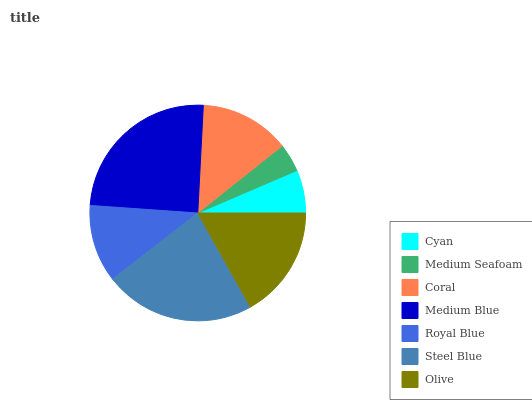Is Medium Seafoam the minimum?
Answer yes or no. Yes. Is Medium Blue the maximum?
Answer yes or no. Yes. Is Coral the minimum?
Answer yes or no. No. Is Coral the maximum?
Answer yes or no. No. Is Coral greater than Medium Seafoam?
Answer yes or no. Yes. Is Medium Seafoam less than Coral?
Answer yes or no. Yes. Is Medium Seafoam greater than Coral?
Answer yes or no. No. Is Coral less than Medium Seafoam?
Answer yes or no. No. Is Coral the high median?
Answer yes or no. Yes. Is Coral the low median?
Answer yes or no. Yes. Is Medium Seafoam the high median?
Answer yes or no. No. Is Olive the low median?
Answer yes or no. No. 